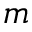<formula> <loc_0><loc_0><loc_500><loc_500>m</formula> 